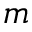<formula> <loc_0><loc_0><loc_500><loc_500>m</formula> 